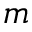<formula> <loc_0><loc_0><loc_500><loc_500>m</formula> 